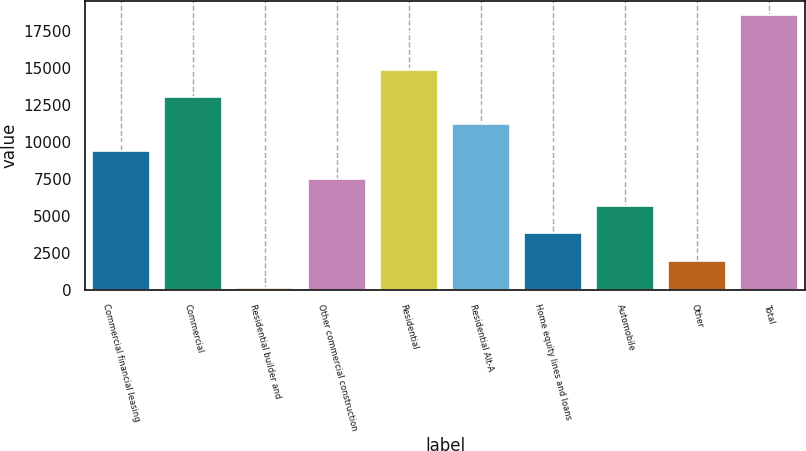<chart> <loc_0><loc_0><loc_500><loc_500><bar_chart><fcel>Commercial financial leasing<fcel>Commercial<fcel>Residential builder and<fcel>Other commercial construction<fcel>Residential<fcel>Residential Alt-A<fcel>Home equity lines and loans<fcel>Automobile<fcel>Other<fcel>Total<nl><fcel>9357.5<fcel>13043.7<fcel>142<fcel>7514.4<fcel>14886.8<fcel>11200.6<fcel>3828.2<fcel>5671.3<fcel>1985.1<fcel>18573<nl></chart> 